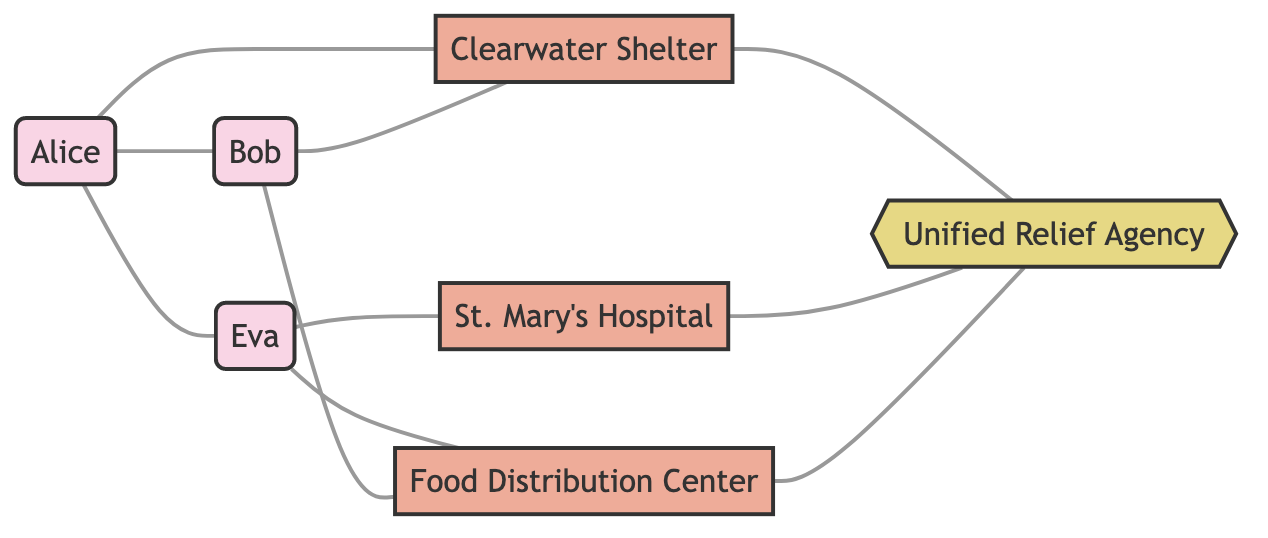What is the total number of individuals in the network? By counting the nodes listed under "individual," we find Alice, Bob, and Eva, which totals three individuals.
Answer: 3 What type of relationship exists between Alice and Eva? The edge labeled with "friend" indicates that Alice and Eva share a friendship, showing a personal connection.
Answer: friend How many resources are managed by the Unified Relief Agency? The edges leading to the Unified Relief Agency from Clearwater Shelter, St. Mary's Hospital, and Food Distribution Center indicate that three resources are managed by this organization.
Answer: 3 Which individual is receiving treatment at St. Mary's Hospital? The edge connecting Eva to St. Mary's Hospital is labeled "receiving_treatment," indicating that Eva is currently the one receiving treatment there.
Answer: Eva How many connections does Bob have in this network? Examining Bob's edges, we see he has connections to Alice (neighbor), Clearwater Shelter (seeking_shelter), and Food Distribution Center (receiving_aid), totaling three connections.
Answer: 3 What is the relationship between the Clearwater Shelter and the Unified Relief Agency? The diagram shows an edge labeled "managed_by," which indicates that the Clearwater Shelter operates under the management of the Unified Relief Agency.
Answer: managed_by Which individual is linked to the food distribution center? Analyzing the diagram, both Eva and Bob are connected to the Food Distribution Center via edges labeled "receiving_aid," indicating they both have access to it.
Answer: Bob, Eva What type of resource is the Clearwater Shelter? The node representing the Clearwater Shelter is categorized as a resource, indicating its role in providing aid to individuals.
Answer: resource How many edges connect individuals to resources? The edges show that Alice, Bob, and Eva each have connections to various resources; upon counting, we find there are five edges connecting individuals to resources.
Answer: 5 What type of resources are represented in the diagram? The nodes list Clearwater Shelter, St. Mary's Hospital, and Food Distribution Center as resources, showing the available types to support individuals in need.
Answer: Clearwater Shelter, St. Mary's Hospital, Food Distribution Center 